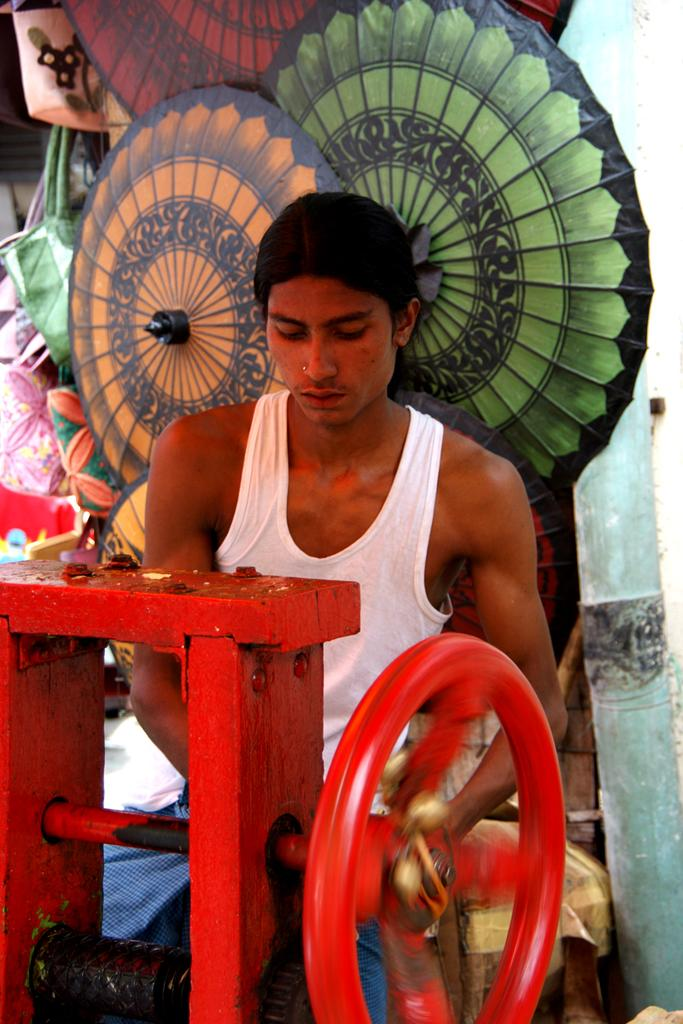What is the main object in the image? There is a machine in the image. What feature does the machine have? The machine has a wheel. Can you describe the background of the image? There is a person, bags, objects, and a wall in the background of the image. What type of cork can be seen in the image? There is no cork present in the image. What kind of polish is the person in the background using? There is no indication in the image that the person in the background is using any polish. 